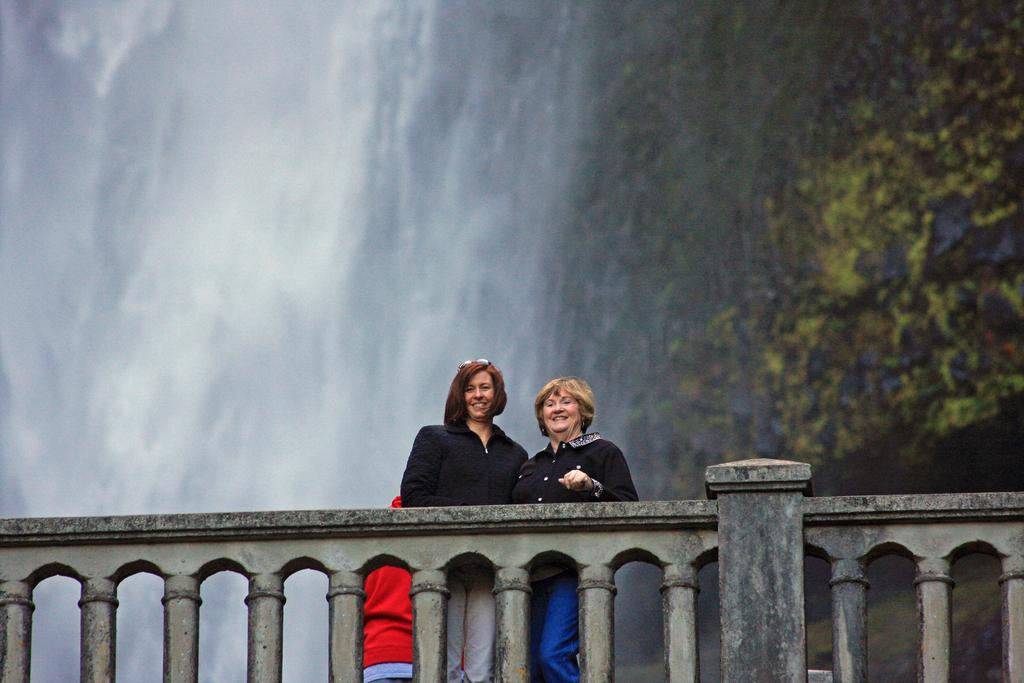What is present in the image that separates the foreground from the background? There is a fence in the image. Who is present behind the fence in the image? Two women are standing behind the fence. What is the facial expression of the women in the image? The women are smiling. What natural feature can be seen in the background of the image? There is a waterfall visible in the background of the image. What type of development is taking place in the cemetery shown in the image? There is no cemetery present in the image; it features a fence, two women, and a waterfall in the background. Can you tell me how many kitties are playing near the waterfall in the image? There are no kitties present in the image; it only features a fence, two women, and a waterfall in the background. 